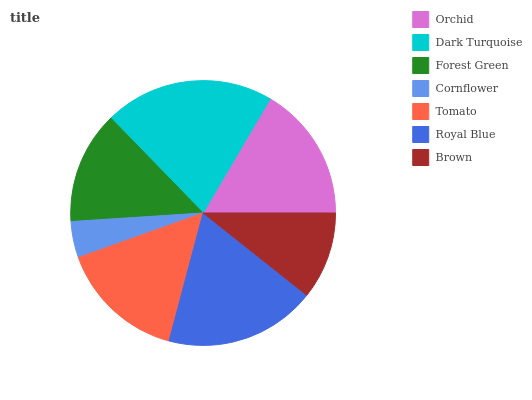Is Cornflower the minimum?
Answer yes or no. Yes. Is Dark Turquoise the maximum?
Answer yes or no. Yes. Is Forest Green the minimum?
Answer yes or no. No. Is Forest Green the maximum?
Answer yes or no. No. Is Dark Turquoise greater than Forest Green?
Answer yes or no. Yes. Is Forest Green less than Dark Turquoise?
Answer yes or no. Yes. Is Forest Green greater than Dark Turquoise?
Answer yes or no. No. Is Dark Turquoise less than Forest Green?
Answer yes or no. No. Is Tomato the high median?
Answer yes or no. Yes. Is Tomato the low median?
Answer yes or no. Yes. Is Orchid the high median?
Answer yes or no. No. Is Dark Turquoise the low median?
Answer yes or no. No. 